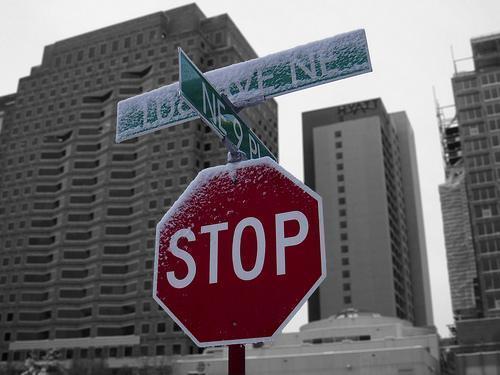How many streets are pictured?
Give a very brief answer. 2. How many signs?
Give a very brief answer. 3. 